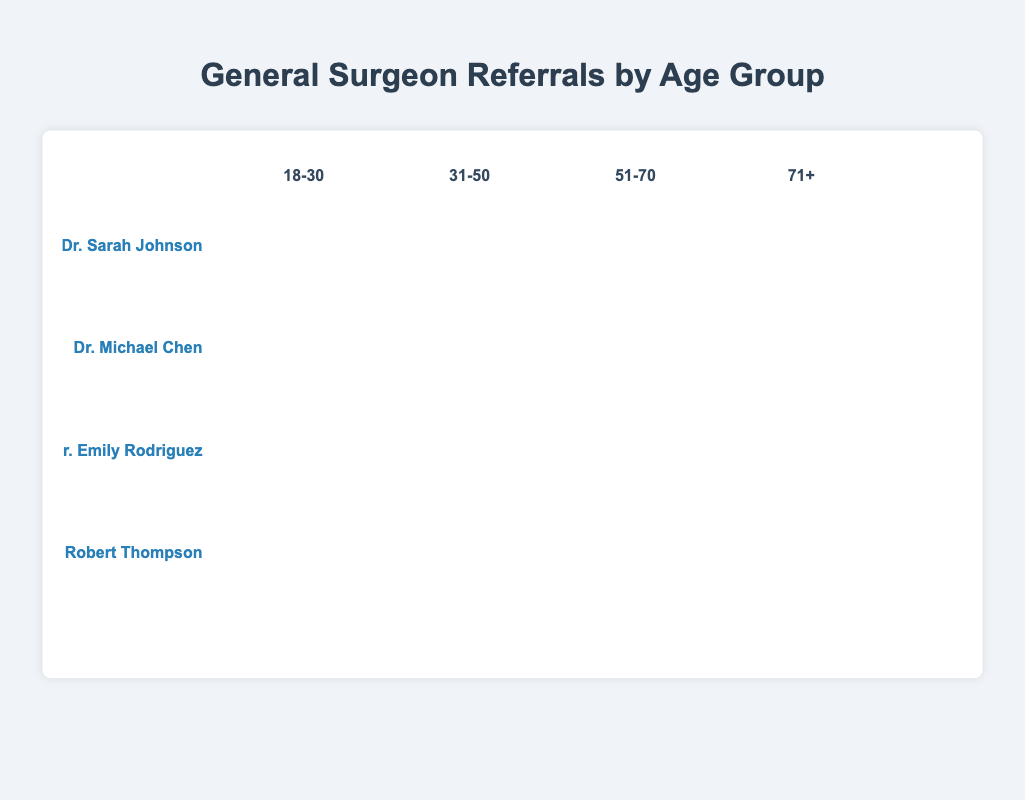What is the total number of referrals for Dr. Sarah Johnson in the 51-70 age group? Sum the number of referrals for Dr. Sarah Johnson for the 51-70 age group. According to the chart, there are 35 referrals.
Answer: 35 Which surgeon has the highest number of referrals in the 71+ age group? Compare the number of referrals in the 71+ age group for all surgeons. Dr. Robert Thompson has the highest with 30 referrals.
Answer: Dr. Robert Thompson How many more referrals does Dr. Michael Chen have compared to Dr. Emily Rodriguez in the 31-50 age group? Subtract the number of referrals for Dr. Emily Rodriguez from Dr. Michael Chen in the 31-50 age group: 30 - 35 = -5. This indicates Dr. Michael Chen has 5 fewer referrals than Dr. Emily Rodriguez.
Answer: 5 fewer What is the total number of referrals across all age groups for Dr. Robert Thompson? Sum the referrals across all age groups for Dr. Robert Thompson: 5 (18-30) + 20 (31-50) + 45 (51-70) + 30 (71+). The total is 100.
Answer: 100 Which age group has the least number of referrals for Dr. Sarah Johnson? Compare the number of referrals across age groups for Dr. Sarah Johnson. The 18-30 age group has the least with 15 referrals.
Answer: 18-30 How many total referrals were made for the surgeons in the 18-30 age group? Sum the number of referrals in the 18-30 age group for all surgeons: 15 (Dr. Sarah Johnson) + 10 (Dr. Michael Chen) + 20 (Dr. Emily Rodriguez) + 5 (Dr. Robert Thompson). The total is 50.
Answer: 50 Who has more referrals, Dr. Sarah Johnson in the 31-50 age group or Dr. Emily Rodriguez in the 71+ age group? Compare the number of referrals: Dr. Sarah Johnson has 25 in the 31-50 age group, while Dr. Emily Rodriguez has 15 in the 71+ age group. Dr. Sarah Johnson has more referrals.
Answer: Dr. Sarah Johnson In which age group does Dr. Michael Chen receive the highest number of referrals? Compare the number of referrals in each age group for Dr. Michael Chen. The 51-70 age group has the highest with 40 referrals.
Answer: 51-70 